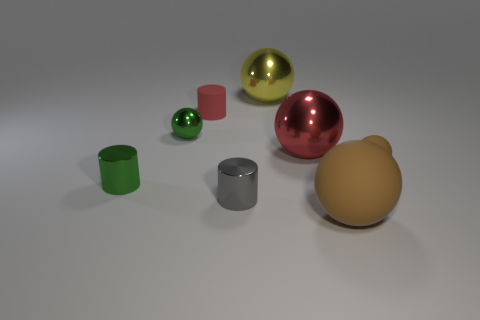Subtract 1 balls. How many balls are left? 4 Subtract all brown balls. How many balls are left? 3 Subtract all small matte spheres. How many spheres are left? 4 Subtract all gray balls. Subtract all gray cylinders. How many balls are left? 5 Add 1 small matte cylinders. How many objects exist? 9 Subtract all spheres. How many objects are left? 3 Add 2 gray cylinders. How many gray cylinders exist? 3 Subtract 0 brown blocks. How many objects are left? 8 Subtract all big brown rubber balls. Subtract all small cyan metal cylinders. How many objects are left? 7 Add 4 brown objects. How many brown objects are left? 6 